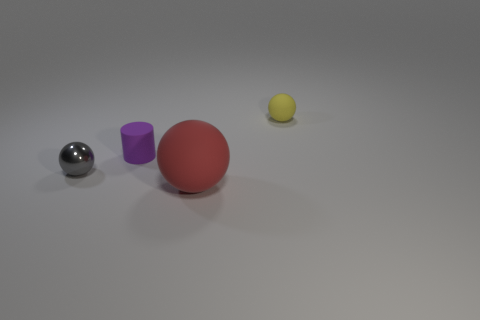Is there any other thing that has the same size as the red ball?
Your answer should be very brief. No. The thing that is right of the tiny purple cylinder and behind the small metallic sphere has what shape?
Ensure brevity in your answer.  Sphere. How many large gray blocks are there?
Your response must be concise. 0. What number of purple things are right of the tiny purple rubber cylinder?
Provide a short and direct response. 0. Is there a tiny gray object of the same shape as the large thing?
Make the answer very short. Yes. Are the yellow object right of the gray shiny object and the tiny sphere that is left of the red rubber object made of the same material?
Make the answer very short. No. There is a rubber object that is in front of the tiny matte thing in front of the tiny ball that is on the right side of the gray thing; what size is it?
Keep it short and to the point. Large. There is a gray object that is the same size as the cylinder; what is its material?
Make the answer very short. Metal. Is there another object that has the same size as the yellow rubber thing?
Provide a succinct answer. Yes. Do the large red thing and the metal object have the same shape?
Your response must be concise. Yes. 